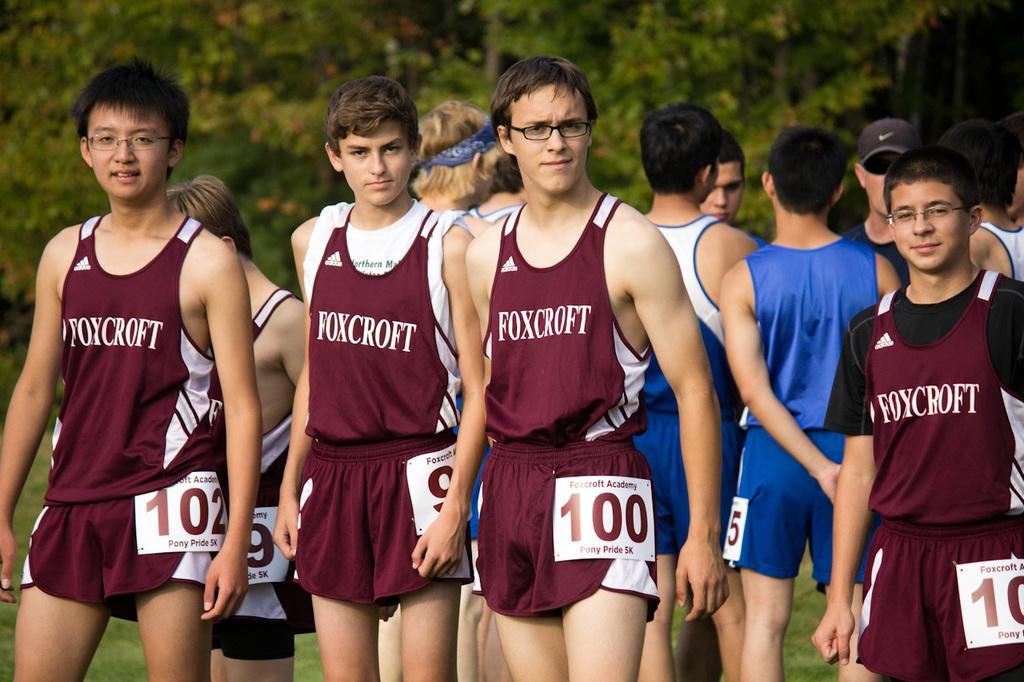What do their shirts say?
Offer a very short reply. Foxcroft. 